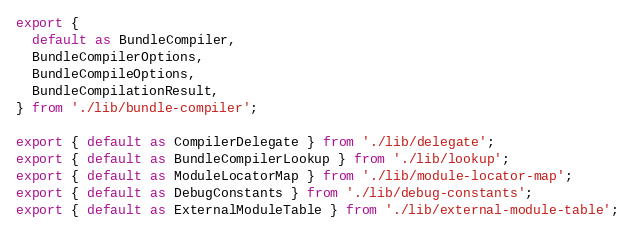Convert code to text. <code><loc_0><loc_0><loc_500><loc_500><_TypeScript_>export {
  default as BundleCompiler,
  BundleCompilerOptions,
  BundleCompileOptions,
  BundleCompilationResult,
} from './lib/bundle-compiler';

export { default as CompilerDelegate } from './lib/delegate';
export { default as BundleCompilerLookup } from './lib/lookup';
export { default as ModuleLocatorMap } from './lib/module-locator-map';
export { default as DebugConstants } from './lib/debug-constants';
export { default as ExternalModuleTable } from './lib/external-module-table';
</code> 